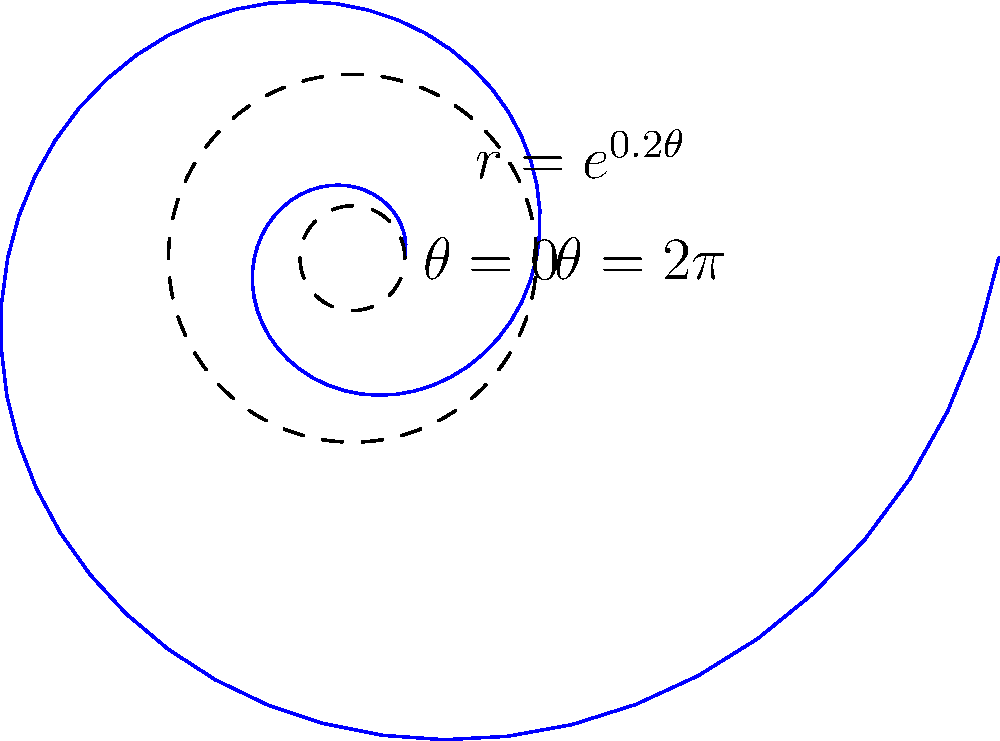In the logarithmic spiral shown above, described by the equation $r = e^{0.2\theta}$, what is the ratio of the spiral's radius at $\theta = 2\pi$ to its radius at $\theta = 0$? Express your answer as a single number rounded to two decimal places. To solve this problem, let's follow these steps:

1) The equation of the logarithmic spiral is given as $r = e^{0.2\theta}$.

2) At $\theta = 0$:
   $r_0 = e^{0.2 \cdot 0} = e^0 = 1$

3) At $\theta = 2\pi$:
   $r_{2\pi} = e^{0.2 \cdot 2\pi} = e^{0.4\pi}$

4) The ratio we're looking for is:
   $\frac{r_{2\pi}}{r_0} = \frac{e^{0.4\pi}}{1} = e^{0.4\pi}$

5) Now, let's calculate this value:
   $e^{0.4\pi} \approx 3.5139$

6) Rounding to two decimal places:
   $e^{0.4\pi} \approx 3.51$

Therefore, the radius of the spiral at $\theta = 2\pi$ is approximately 3.51 times larger than its radius at $\theta = 0$.
Answer: 3.51 